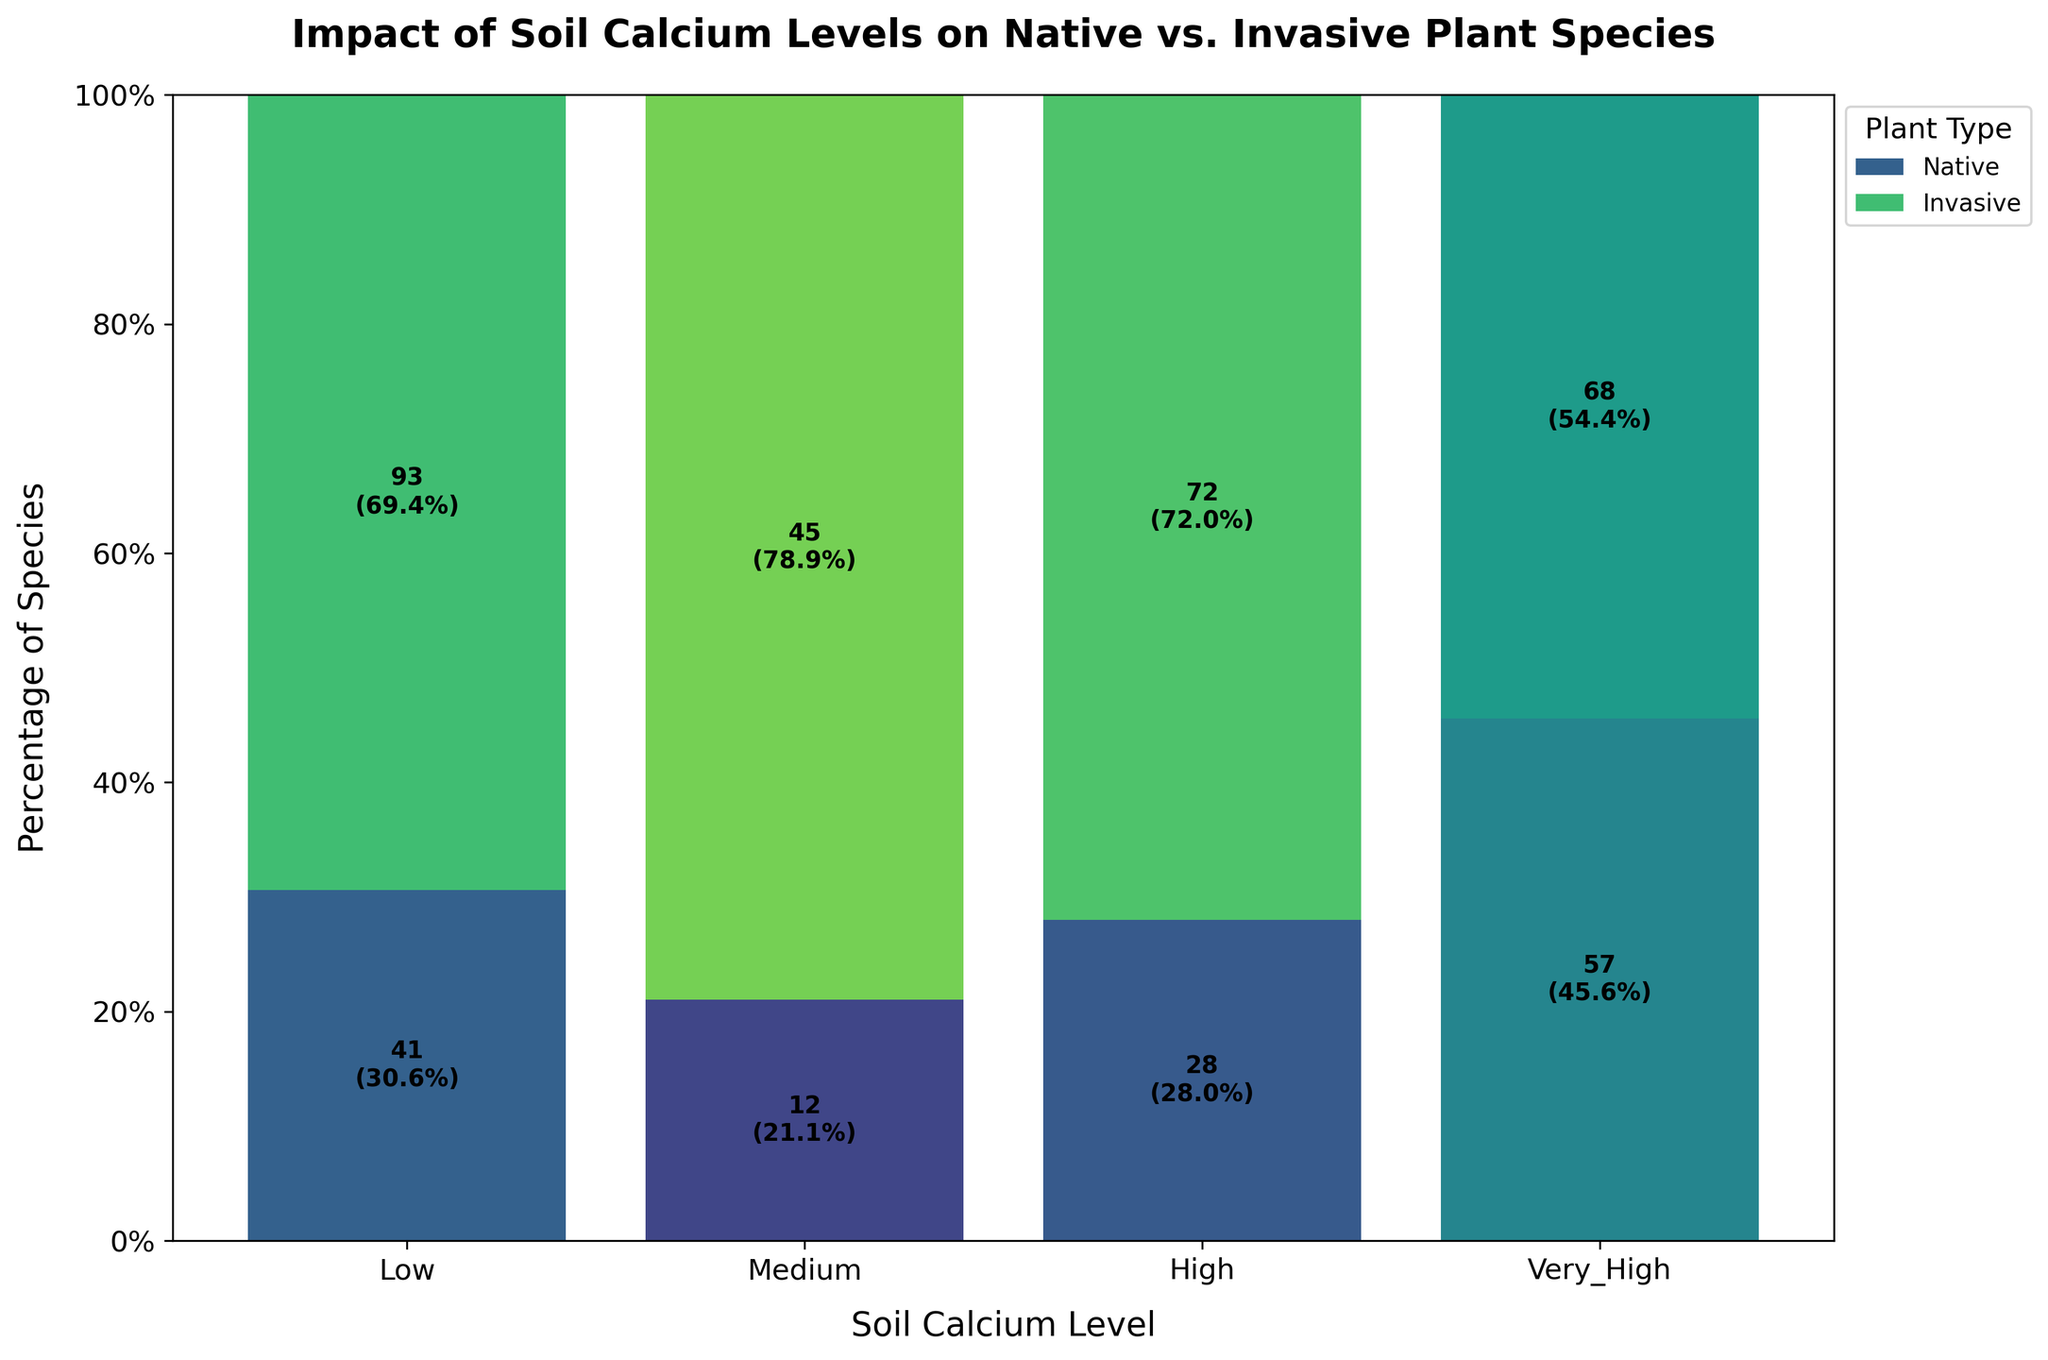What is the title of the plot? The title of the plot is usually located at the top center of the figure and provides an overview of the plot's context. The title in this case is "Impact of Soil Calcium Levels on Native vs. Invasive Plant Species".
Answer: Impact of Soil Calcium Levels on Native vs. Invasive Plant Species Which soil calcium level has the highest percentage of invasive plant species? Look at the y-axis values, which show percentages. Observe the bar sections corresponding to invasive plant species in each soil calcium level. The "Very High" level has the tallest section for invasive species.
Answer: Very High What percentage of native plant species is there at medium soil calcium level? Identify the segment for the native plant species in the medium soil calcium level bar and read the percentage value from the y-axis. You can also refer to the value label directly on the bar.
Answer: 72% How many invasive plant species are there in the high soil calcium level? Locate the invasive plant species segment in the high soil calcium level bar and read the count label directly on the bar. It shows the exact number of species.
Answer: 41 Compare the number of native species in low and very high soil calcium levels. Which level has more native species, and by how much? Identify the native plant species count on both the low and very high soil calcium level bars. Subtract the count of the low level from the count of the very high level. There are 68 native species in very high and 45 in low. So, 68 - 45 = 23.
Answer: Very High, by 23 Is there a soil calcium level where native plant species are less than invasive species? If yes, which level? Compare the visual height and count of segments of native and invasive species across all calcium levels. Native species are less than invasive species at the "Very High" calcium level as indicated by the count labels and segment height on the bar.
Answer: Very High What is the combined percentage of native and invasive species at the high soil calcium level? In a mosaic plot, the total for each category should sum to 100%. However, since we are examining percentages within a single category (high soil calcium), it's 100% because it's the total contribution of both types of plants.
Answer: 100% What is the difference in the percentage of invasive species between medium and very high soil calcium levels? Identify the percentage of invasive species in medium and very high soil calcium levels. For medium, it’s 28%, and for very high, it’s 57%. Compute the difference: 57% - 28% = 29%.
Answer: 29% Which plant type shows a consistent increase in percentage across increasing soil calcium levels? Observe the changes in percentages for each plant type as soil calcium levels increase. The native plant species show an overall increase from low to high calcium levels, excluding the drop at "Very High".
Answer: Native plant species 